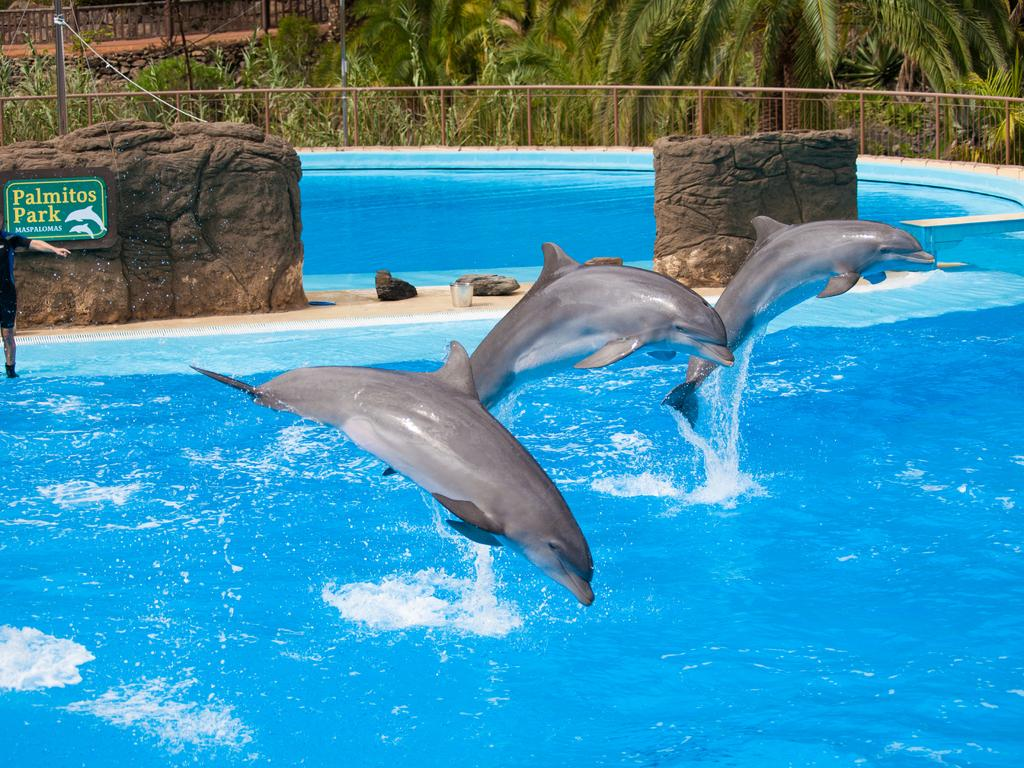What is at the bottom of the image? There is water at the bottom of the image. What animals can be seen in the foreground? Dolphins are visible in the foreground. What type of landscape elements are present in the background? There are rocks, water, trees, and fencing in the background. What is the reaction of the dolphins to the sound of the waves in the image? There is no indication of the dolphins' reaction to the sound of the waves in the image, as it does not depict any sound or reaction. 